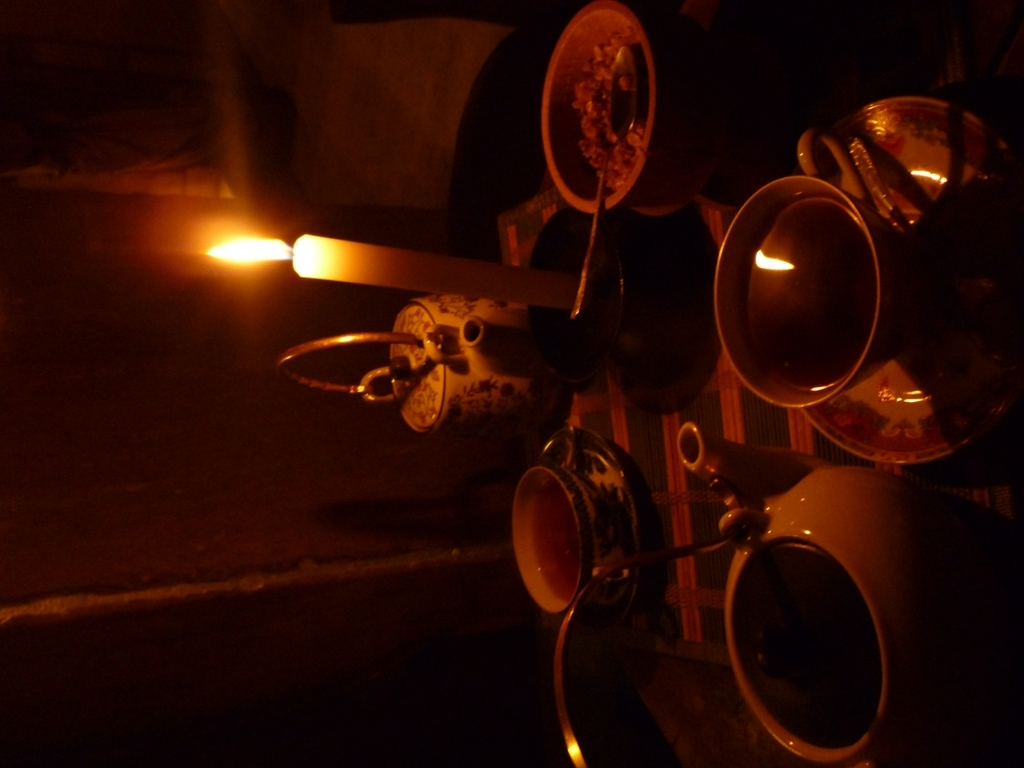Is the clarity of the image acceptable? While the image is somewhat dark and may seem unclear at first glance, the dim lighting appears intentional to create an ambiance. The visible elements such as the candle, teacups, and teapot suggest a tranquil evening setting, where the subjects are illuminated subtly by the candlelight. This deliberate lighting choice conveys a mood and therefore, within the context of the scene, the clarity is indeed acceptable. 